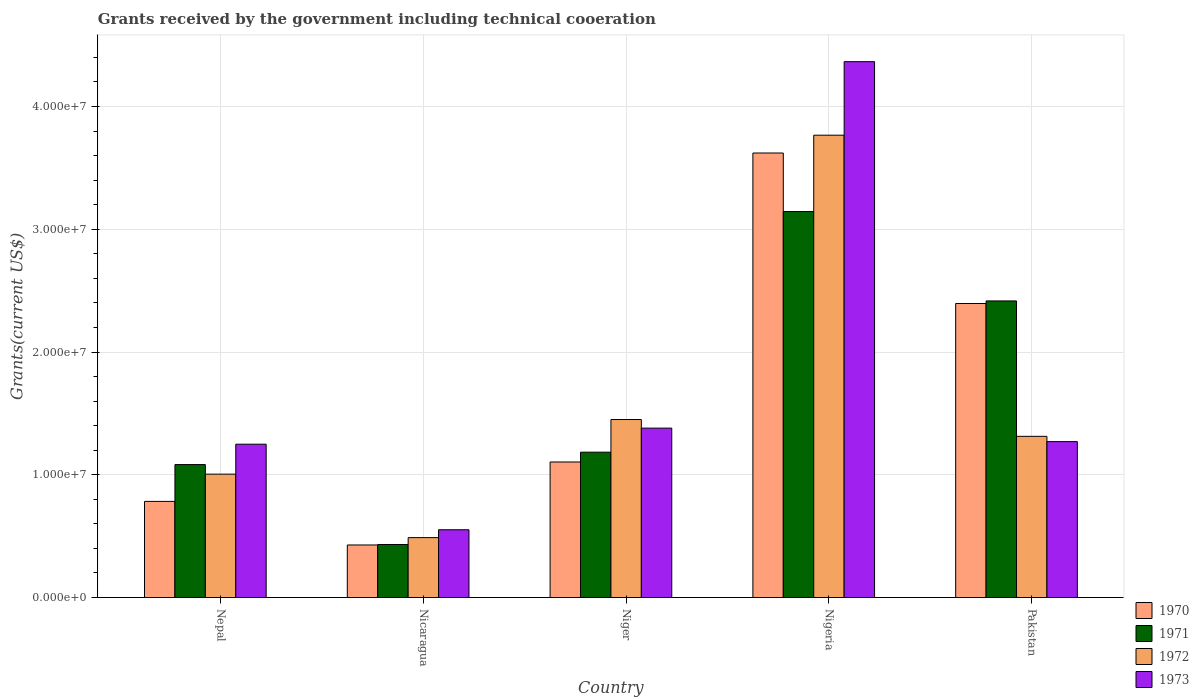Are the number of bars on each tick of the X-axis equal?
Offer a very short reply. Yes. How many bars are there on the 2nd tick from the right?
Provide a short and direct response. 4. What is the label of the 3rd group of bars from the left?
Provide a short and direct response. Niger. What is the total grants received by the government in 1970 in Nigeria?
Offer a terse response. 3.62e+07. Across all countries, what is the maximum total grants received by the government in 1973?
Your answer should be compact. 4.36e+07. Across all countries, what is the minimum total grants received by the government in 1972?
Offer a terse response. 4.88e+06. In which country was the total grants received by the government in 1972 maximum?
Your answer should be very brief. Nigeria. In which country was the total grants received by the government in 1972 minimum?
Offer a terse response. Nicaragua. What is the total total grants received by the government in 1970 in the graph?
Your answer should be very brief. 8.33e+07. What is the difference between the total grants received by the government in 1970 in Nepal and that in Niger?
Your response must be concise. -3.21e+06. What is the difference between the total grants received by the government in 1973 in Nicaragua and the total grants received by the government in 1972 in Nigeria?
Offer a very short reply. -3.21e+07. What is the average total grants received by the government in 1972 per country?
Offer a terse response. 1.60e+07. What is the difference between the total grants received by the government of/in 1972 and total grants received by the government of/in 1971 in Niger?
Your answer should be very brief. 2.66e+06. In how many countries, is the total grants received by the government in 1971 greater than 12000000 US$?
Provide a short and direct response. 2. What is the ratio of the total grants received by the government in 1973 in Nepal to that in Nicaragua?
Your response must be concise. 2.26. Is the total grants received by the government in 1971 in Niger less than that in Nigeria?
Give a very brief answer. Yes. Is the difference between the total grants received by the government in 1972 in Nepal and Pakistan greater than the difference between the total grants received by the government in 1971 in Nepal and Pakistan?
Your answer should be compact. Yes. What is the difference between the highest and the second highest total grants received by the government in 1972?
Offer a very short reply. 2.45e+07. What is the difference between the highest and the lowest total grants received by the government in 1972?
Offer a very short reply. 3.28e+07. Is the sum of the total grants received by the government in 1970 in Niger and Nigeria greater than the maximum total grants received by the government in 1971 across all countries?
Your answer should be very brief. Yes. Is it the case that in every country, the sum of the total grants received by the government in 1973 and total grants received by the government in 1972 is greater than the total grants received by the government in 1971?
Provide a succinct answer. Yes. Are all the bars in the graph horizontal?
Provide a short and direct response. No. How many countries are there in the graph?
Ensure brevity in your answer.  5. How are the legend labels stacked?
Provide a succinct answer. Vertical. What is the title of the graph?
Your response must be concise. Grants received by the government including technical cooeration. Does "1996" appear as one of the legend labels in the graph?
Your answer should be very brief. No. What is the label or title of the X-axis?
Offer a terse response. Country. What is the label or title of the Y-axis?
Provide a short and direct response. Grants(current US$). What is the Grants(current US$) of 1970 in Nepal?
Give a very brief answer. 7.83e+06. What is the Grants(current US$) in 1971 in Nepal?
Your response must be concise. 1.08e+07. What is the Grants(current US$) of 1972 in Nepal?
Provide a succinct answer. 1.00e+07. What is the Grants(current US$) of 1973 in Nepal?
Offer a terse response. 1.25e+07. What is the Grants(current US$) of 1970 in Nicaragua?
Offer a terse response. 4.28e+06. What is the Grants(current US$) in 1971 in Nicaragua?
Your response must be concise. 4.32e+06. What is the Grants(current US$) in 1972 in Nicaragua?
Offer a terse response. 4.88e+06. What is the Grants(current US$) of 1973 in Nicaragua?
Make the answer very short. 5.52e+06. What is the Grants(current US$) in 1970 in Niger?
Provide a short and direct response. 1.10e+07. What is the Grants(current US$) of 1971 in Niger?
Make the answer very short. 1.18e+07. What is the Grants(current US$) of 1972 in Niger?
Make the answer very short. 1.45e+07. What is the Grants(current US$) of 1973 in Niger?
Offer a terse response. 1.38e+07. What is the Grants(current US$) of 1970 in Nigeria?
Your answer should be compact. 3.62e+07. What is the Grants(current US$) in 1971 in Nigeria?
Give a very brief answer. 3.14e+07. What is the Grants(current US$) in 1972 in Nigeria?
Give a very brief answer. 3.77e+07. What is the Grants(current US$) in 1973 in Nigeria?
Offer a terse response. 4.36e+07. What is the Grants(current US$) in 1970 in Pakistan?
Offer a terse response. 2.40e+07. What is the Grants(current US$) of 1971 in Pakistan?
Offer a terse response. 2.42e+07. What is the Grants(current US$) of 1972 in Pakistan?
Ensure brevity in your answer.  1.31e+07. What is the Grants(current US$) of 1973 in Pakistan?
Make the answer very short. 1.27e+07. Across all countries, what is the maximum Grants(current US$) in 1970?
Give a very brief answer. 3.62e+07. Across all countries, what is the maximum Grants(current US$) of 1971?
Give a very brief answer. 3.14e+07. Across all countries, what is the maximum Grants(current US$) of 1972?
Offer a very short reply. 3.77e+07. Across all countries, what is the maximum Grants(current US$) in 1973?
Offer a terse response. 4.36e+07. Across all countries, what is the minimum Grants(current US$) in 1970?
Ensure brevity in your answer.  4.28e+06. Across all countries, what is the minimum Grants(current US$) of 1971?
Ensure brevity in your answer.  4.32e+06. Across all countries, what is the minimum Grants(current US$) in 1972?
Your response must be concise. 4.88e+06. Across all countries, what is the minimum Grants(current US$) of 1973?
Offer a very short reply. 5.52e+06. What is the total Grants(current US$) of 1970 in the graph?
Your answer should be compact. 8.33e+07. What is the total Grants(current US$) of 1971 in the graph?
Your answer should be very brief. 8.26e+07. What is the total Grants(current US$) in 1972 in the graph?
Offer a very short reply. 8.02e+07. What is the total Grants(current US$) in 1973 in the graph?
Keep it short and to the point. 8.82e+07. What is the difference between the Grants(current US$) of 1970 in Nepal and that in Nicaragua?
Keep it short and to the point. 3.55e+06. What is the difference between the Grants(current US$) of 1971 in Nepal and that in Nicaragua?
Make the answer very short. 6.51e+06. What is the difference between the Grants(current US$) in 1972 in Nepal and that in Nicaragua?
Offer a very short reply. 5.17e+06. What is the difference between the Grants(current US$) in 1973 in Nepal and that in Nicaragua?
Offer a terse response. 6.97e+06. What is the difference between the Grants(current US$) of 1970 in Nepal and that in Niger?
Offer a terse response. -3.21e+06. What is the difference between the Grants(current US$) in 1971 in Nepal and that in Niger?
Keep it short and to the point. -1.01e+06. What is the difference between the Grants(current US$) of 1972 in Nepal and that in Niger?
Your response must be concise. -4.45e+06. What is the difference between the Grants(current US$) of 1973 in Nepal and that in Niger?
Keep it short and to the point. -1.31e+06. What is the difference between the Grants(current US$) of 1970 in Nepal and that in Nigeria?
Your response must be concise. -2.84e+07. What is the difference between the Grants(current US$) in 1971 in Nepal and that in Nigeria?
Your response must be concise. -2.06e+07. What is the difference between the Grants(current US$) in 1972 in Nepal and that in Nigeria?
Give a very brief answer. -2.76e+07. What is the difference between the Grants(current US$) of 1973 in Nepal and that in Nigeria?
Offer a terse response. -3.12e+07. What is the difference between the Grants(current US$) of 1970 in Nepal and that in Pakistan?
Provide a short and direct response. -1.61e+07. What is the difference between the Grants(current US$) in 1971 in Nepal and that in Pakistan?
Your answer should be very brief. -1.33e+07. What is the difference between the Grants(current US$) of 1972 in Nepal and that in Pakistan?
Give a very brief answer. -3.08e+06. What is the difference between the Grants(current US$) of 1973 in Nepal and that in Pakistan?
Offer a very short reply. -2.10e+05. What is the difference between the Grants(current US$) of 1970 in Nicaragua and that in Niger?
Offer a terse response. -6.76e+06. What is the difference between the Grants(current US$) of 1971 in Nicaragua and that in Niger?
Offer a terse response. -7.52e+06. What is the difference between the Grants(current US$) in 1972 in Nicaragua and that in Niger?
Provide a short and direct response. -9.62e+06. What is the difference between the Grants(current US$) in 1973 in Nicaragua and that in Niger?
Make the answer very short. -8.28e+06. What is the difference between the Grants(current US$) in 1970 in Nicaragua and that in Nigeria?
Keep it short and to the point. -3.19e+07. What is the difference between the Grants(current US$) in 1971 in Nicaragua and that in Nigeria?
Provide a short and direct response. -2.71e+07. What is the difference between the Grants(current US$) of 1972 in Nicaragua and that in Nigeria?
Your answer should be compact. -3.28e+07. What is the difference between the Grants(current US$) in 1973 in Nicaragua and that in Nigeria?
Your response must be concise. -3.81e+07. What is the difference between the Grants(current US$) of 1970 in Nicaragua and that in Pakistan?
Provide a succinct answer. -1.97e+07. What is the difference between the Grants(current US$) of 1971 in Nicaragua and that in Pakistan?
Offer a terse response. -1.98e+07. What is the difference between the Grants(current US$) of 1972 in Nicaragua and that in Pakistan?
Provide a succinct answer. -8.25e+06. What is the difference between the Grants(current US$) of 1973 in Nicaragua and that in Pakistan?
Your answer should be compact. -7.18e+06. What is the difference between the Grants(current US$) of 1970 in Niger and that in Nigeria?
Give a very brief answer. -2.52e+07. What is the difference between the Grants(current US$) in 1971 in Niger and that in Nigeria?
Make the answer very short. -1.96e+07. What is the difference between the Grants(current US$) of 1972 in Niger and that in Nigeria?
Offer a terse response. -2.32e+07. What is the difference between the Grants(current US$) in 1973 in Niger and that in Nigeria?
Your answer should be very brief. -2.98e+07. What is the difference between the Grants(current US$) in 1970 in Niger and that in Pakistan?
Make the answer very short. -1.29e+07. What is the difference between the Grants(current US$) of 1971 in Niger and that in Pakistan?
Provide a succinct answer. -1.23e+07. What is the difference between the Grants(current US$) of 1972 in Niger and that in Pakistan?
Provide a short and direct response. 1.37e+06. What is the difference between the Grants(current US$) in 1973 in Niger and that in Pakistan?
Keep it short and to the point. 1.10e+06. What is the difference between the Grants(current US$) in 1970 in Nigeria and that in Pakistan?
Your response must be concise. 1.23e+07. What is the difference between the Grants(current US$) in 1971 in Nigeria and that in Pakistan?
Offer a very short reply. 7.28e+06. What is the difference between the Grants(current US$) of 1972 in Nigeria and that in Pakistan?
Your answer should be compact. 2.45e+07. What is the difference between the Grants(current US$) in 1973 in Nigeria and that in Pakistan?
Your answer should be compact. 3.10e+07. What is the difference between the Grants(current US$) in 1970 in Nepal and the Grants(current US$) in 1971 in Nicaragua?
Your response must be concise. 3.51e+06. What is the difference between the Grants(current US$) of 1970 in Nepal and the Grants(current US$) of 1972 in Nicaragua?
Provide a succinct answer. 2.95e+06. What is the difference between the Grants(current US$) in 1970 in Nepal and the Grants(current US$) in 1973 in Nicaragua?
Ensure brevity in your answer.  2.31e+06. What is the difference between the Grants(current US$) in 1971 in Nepal and the Grants(current US$) in 1972 in Nicaragua?
Ensure brevity in your answer.  5.95e+06. What is the difference between the Grants(current US$) of 1971 in Nepal and the Grants(current US$) of 1973 in Nicaragua?
Offer a terse response. 5.31e+06. What is the difference between the Grants(current US$) in 1972 in Nepal and the Grants(current US$) in 1973 in Nicaragua?
Your answer should be very brief. 4.53e+06. What is the difference between the Grants(current US$) of 1970 in Nepal and the Grants(current US$) of 1971 in Niger?
Ensure brevity in your answer.  -4.01e+06. What is the difference between the Grants(current US$) in 1970 in Nepal and the Grants(current US$) in 1972 in Niger?
Your answer should be very brief. -6.67e+06. What is the difference between the Grants(current US$) in 1970 in Nepal and the Grants(current US$) in 1973 in Niger?
Keep it short and to the point. -5.97e+06. What is the difference between the Grants(current US$) of 1971 in Nepal and the Grants(current US$) of 1972 in Niger?
Your answer should be compact. -3.67e+06. What is the difference between the Grants(current US$) in 1971 in Nepal and the Grants(current US$) in 1973 in Niger?
Your answer should be very brief. -2.97e+06. What is the difference between the Grants(current US$) of 1972 in Nepal and the Grants(current US$) of 1973 in Niger?
Keep it short and to the point. -3.75e+06. What is the difference between the Grants(current US$) in 1970 in Nepal and the Grants(current US$) in 1971 in Nigeria?
Your response must be concise. -2.36e+07. What is the difference between the Grants(current US$) of 1970 in Nepal and the Grants(current US$) of 1972 in Nigeria?
Provide a succinct answer. -2.98e+07. What is the difference between the Grants(current US$) in 1970 in Nepal and the Grants(current US$) in 1973 in Nigeria?
Ensure brevity in your answer.  -3.58e+07. What is the difference between the Grants(current US$) of 1971 in Nepal and the Grants(current US$) of 1972 in Nigeria?
Offer a terse response. -2.68e+07. What is the difference between the Grants(current US$) in 1971 in Nepal and the Grants(current US$) in 1973 in Nigeria?
Your answer should be very brief. -3.28e+07. What is the difference between the Grants(current US$) of 1972 in Nepal and the Grants(current US$) of 1973 in Nigeria?
Your answer should be compact. -3.36e+07. What is the difference between the Grants(current US$) of 1970 in Nepal and the Grants(current US$) of 1971 in Pakistan?
Offer a very short reply. -1.63e+07. What is the difference between the Grants(current US$) in 1970 in Nepal and the Grants(current US$) in 1972 in Pakistan?
Your response must be concise. -5.30e+06. What is the difference between the Grants(current US$) of 1970 in Nepal and the Grants(current US$) of 1973 in Pakistan?
Keep it short and to the point. -4.87e+06. What is the difference between the Grants(current US$) in 1971 in Nepal and the Grants(current US$) in 1972 in Pakistan?
Your answer should be very brief. -2.30e+06. What is the difference between the Grants(current US$) in 1971 in Nepal and the Grants(current US$) in 1973 in Pakistan?
Ensure brevity in your answer.  -1.87e+06. What is the difference between the Grants(current US$) of 1972 in Nepal and the Grants(current US$) of 1973 in Pakistan?
Make the answer very short. -2.65e+06. What is the difference between the Grants(current US$) of 1970 in Nicaragua and the Grants(current US$) of 1971 in Niger?
Provide a succinct answer. -7.56e+06. What is the difference between the Grants(current US$) in 1970 in Nicaragua and the Grants(current US$) in 1972 in Niger?
Make the answer very short. -1.02e+07. What is the difference between the Grants(current US$) of 1970 in Nicaragua and the Grants(current US$) of 1973 in Niger?
Offer a terse response. -9.52e+06. What is the difference between the Grants(current US$) of 1971 in Nicaragua and the Grants(current US$) of 1972 in Niger?
Provide a short and direct response. -1.02e+07. What is the difference between the Grants(current US$) in 1971 in Nicaragua and the Grants(current US$) in 1973 in Niger?
Ensure brevity in your answer.  -9.48e+06. What is the difference between the Grants(current US$) of 1972 in Nicaragua and the Grants(current US$) of 1973 in Niger?
Offer a terse response. -8.92e+06. What is the difference between the Grants(current US$) in 1970 in Nicaragua and the Grants(current US$) in 1971 in Nigeria?
Your response must be concise. -2.72e+07. What is the difference between the Grants(current US$) in 1970 in Nicaragua and the Grants(current US$) in 1972 in Nigeria?
Your answer should be compact. -3.34e+07. What is the difference between the Grants(current US$) of 1970 in Nicaragua and the Grants(current US$) of 1973 in Nigeria?
Ensure brevity in your answer.  -3.94e+07. What is the difference between the Grants(current US$) in 1971 in Nicaragua and the Grants(current US$) in 1972 in Nigeria?
Your answer should be very brief. -3.33e+07. What is the difference between the Grants(current US$) in 1971 in Nicaragua and the Grants(current US$) in 1973 in Nigeria?
Ensure brevity in your answer.  -3.93e+07. What is the difference between the Grants(current US$) in 1972 in Nicaragua and the Grants(current US$) in 1973 in Nigeria?
Your answer should be compact. -3.88e+07. What is the difference between the Grants(current US$) of 1970 in Nicaragua and the Grants(current US$) of 1971 in Pakistan?
Offer a terse response. -1.99e+07. What is the difference between the Grants(current US$) in 1970 in Nicaragua and the Grants(current US$) in 1972 in Pakistan?
Make the answer very short. -8.85e+06. What is the difference between the Grants(current US$) of 1970 in Nicaragua and the Grants(current US$) of 1973 in Pakistan?
Keep it short and to the point. -8.42e+06. What is the difference between the Grants(current US$) in 1971 in Nicaragua and the Grants(current US$) in 1972 in Pakistan?
Keep it short and to the point. -8.81e+06. What is the difference between the Grants(current US$) of 1971 in Nicaragua and the Grants(current US$) of 1973 in Pakistan?
Offer a very short reply. -8.38e+06. What is the difference between the Grants(current US$) in 1972 in Nicaragua and the Grants(current US$) in 1973 in Pakistan?
Make the answer very short. -7.82e+06. What is the difference between the Grants(current US$) in 1970 in Niger and the Grants(current US$) in 1971 in Nigeria?
Give a very brief answer. -2.04e+07. What is the difference between the Grants(current US$) of 1970 in Niger and the Grants(current US$) of 1972 in Nigeria?
Ensure brevity in your answer.  -2.66e+07. What is the difference between the Grants(current US$) of 1970 in Niger and the Grants(current US$) of 1973 in Nigeria?
Your answer should be very brief. -3.26e+07. What is the difference between the Grants(current US$) in 1971 in Niger and the Grants(current US$) in 1972 in Nigeria?
Give a very brief answer. -2.58e+07. What is the difference between the Grants(current US$) in 1971 in Niger and the Grants(current US$) in 1973 in Nigeria?
Give a very brief answer. -3.18e+07. What is the difference between the Grants(current US$) in 1972 in Niger and the Grants(current US$) in 1973 in Nigeria?
Provide a succinct answer. -2.92e+07. What is the difference between the Grants(current US$) in 1970 in Niger and the Grants(current US$) in 1971 in Pakistan?
Ensure brevity in your answer.  -1.31e+07. What is the difference between the Grants(current US$) in 1970 in Niger and the Grants(current US$) in 1972 in Pakistan?
Your answer should be compact. -2.09e+06. What is the difference between the Grants(current US$) in 1970 in Niger and the Grants(current US$) in 1973 in Pakistan?
Give a very brief answer. -1.66e+06. What is the difference between the Grants(current US$) of 1971 in Niger and the Grants(current US$) of 1972 in Pakistan?
Keep it short and to the point. -1.29e+06. What is the difference between the Grants(current US$) in 1971 in Niger and the Grants(current US$) in 1973 in Pakistan?
Provide a short and direct response. -8.60e+05. What is the difference between the Grants(current US$) in 1972 in Niger and the Grants(current US$) in 1973 in Pakistan?
Provide a succinct answer. 1.80e+06. What is the difference between the Grants(current US$) in 1970 in Nigeria and the Grants(current US$) in 1971 in Pakistan?
Provide a short and direct response. 1.20e+07. What is the difference between the Grants(current US$) of 1970 in Nigeria and the Grants(current US$) of 1972 in Pakistan?
Offer a very short reply. 2.31e+07. What is the difference between the Grants(current US$) in 1970 in Nigeria and the Grants(current US$) in 1973 in Pakistan?
Keep it short and to the point. 2.35e+07. What is the difference between the Grants(current US$) in 1971 in Nigeria and the Grants(current US$) in 1972 in Pakistan?
Offer a terse response. 1.83e+07. What is the difference between the Grants(current US$) in 1971 in Nigeria and the Grants(current US$) in 1973 in Pakistan?
Provide a short and direct response. 1.87e+07. What is the difference between the Grants(current US$) in 1972 in Nigeria and the Grants(current US$) in 1973 in Pakistan?
Your answer should be compact. 2.50e+07. What is the average Grants(current US$) in 1970 per country?
Ensure brevity in your answer.  1.67e+07. What is the average Grants(current US$) in 1971 per country?
Your answer should be very brief. 1.65e+07. What is the average Grants(current US$) of 1972 per country?
Provide a succinct answer. 1.60e+07. What is the average Grants(current US$) in 1973 per country?
Provide a succinct answer. 1.76e+07. What is the difference between the Grants(current US$) of 1970 and Grants(current US$) of 1971 in Nepal?
Offer a very short reply. -3.00e+06. What is the difference between the Grants(current US$) in 1970 and Grants(current US$) in 1972 in Nepal?
Provide a short and direct response. -2.22e+06. What is the difference between the Grants(current US$) in 1970 and Grants(current US$) in 1973 in Nepal?
Offer a very short reply. -4.66e+06. What is the difference between the Grants(current US$) of 1971 and Grants(current US$) of 1972 in Nepal?
Your response must be concise. 7.80e+05. What is the difference between the Grants(current US$) of 1971 and Grants(current US$) of 1973 in Nepal?
Your answer should be compact. -1.66e+06. What is the difference between the Grants(current US$) of 1972 and Grants(current US$) of 1973 in Nepal?
Offer a very short reply. -2.44e+06. What is the difference between the Grants(current US$) of 1970 and Grants(current US$) of 1972 in Nicaragua?
Offer a terse response. -6.00e+05. What is the difference between the Grants(current US$) of 1970 and Grants(current US$) of 1973 in Nicaragua?
Offer a very short reply. -1.24e+06. What is the difference between the Grants(current US$) in 1971 and Grants(current US$) in 1972 in Nicaragua?
Give a very brief answer. -5.60e+05. What is the difference between the Grants(current US$) of 1971 and Grants(current US$) of 1973 in Nicaragua?
Make the answer very short. -1.20e+06. What is the difference between the Grants(current US$) in 1972 and Grants(current US$) in 1973 in Nicaragua?
Your response must be concise. -6.40e+05. What is the difference between the Grants(current US$) in 1970 and Grants(current US$) in 1971 in Niger?
Give a very brief answer. -8.00e+05. What is the difference between the Grants(current US$) in 1970 and Grants(current US$) in 1972 in Niger?
Offer a very short reply. -3.46e+06. What is the difference between the Grants(current US$) in 1970 and Grants(current US$) in 1973 in Niger?
Offer a very short reply. -2.76e+06. What is the difference between the Grants(current US$) in 1971 and Grants(current US$) in 1972 in Niger?
Keep it short and to the point. -2.66e+06. What is the difference between the Grants(current US$) in 1971 and Grants(current US$) in 1973 in Niger?
Give a very brief answer. -1.96e+06. What is the difference between the Grants(current US$) in 1970 and Grants(current US$) in 1971 in Nigeria?
Your answer should be compact. 4.77e+06. What is the difference between the Grants(current US$) in 1970 and Grants(current US$) in 1972 in Nigeria?
Offer a terse response. -1.45e+06. What is the difference between the Grants(current US$) of 1970 and Grants(current US$) of 1973 in Nigeria?
Your answer should be very brief. -7.44e+06. What is the difference between the Grants(current US$) of 1971 and Grants(current US$) of 1972 in Nigeria?
Keep it short and to the point. -6.22e+06. What is the difference between the Grants(current US$) in 1971 and Grants(current US$) in 1973 in Nigeria?
Make the answer very short. -1.22e+07. What is the difference between the Grants(current US$) in 1972 and Grants(current US$) in 1973 in Nigeria?
Make the answer very short. -5.99e+06. What is the difference between the Grants(current US$) in 1970 and Grants(current US$) in 1971 in Pakistan?
Your answer should be very brief. -2.10e+05. What is the difference between the Grants(current US$) in 1970 and Grants(current US$) in 1972 in Pakistan?
Provide a short and direct response. 1.08e+07. What is the difference between the Grants(current US$) of 1970 and Grants(current US$) of 1973 in Pakistan?
Keep it short and to the point. 1.12e+07. What is the difference between the Grants(current US$) in 1971 and Grants(current US$) in 1972 in Pakistan?
Provide a succinct answer. 1.10e+07. What is the difference between the Grants(current US$) of 1971 and Grants(current US$) of 1973 in Pakistan?
Your answer should be very brief. 1.15e+07. What is the ratio of the Grants(current US$) in 1970 in Nepal to that in Nicaragua?
Ensure brevity in your answer.  1.83. What is the ratio of the Grants(current US$) of 1971 in Nepal to that in Nicaragua?
Your response must be concise. 2.51. What is the ratio of the Grants(current US$) of 1972 in Nepal to that in Nicaragua?
Your answer should be very brief. 2.06. What is the ratio of the Grants(current US$) of 1973 in Nepal to that in Nicaragua?
Make the answer very short. 2.26. What is the ratio of the Grants(current US$) in 1970 in Nepal to that in Niger?
Provide a succinct answer. 0.71. What is the ratio of the Grants(current US$) of 1971 in Nepal to that in Niger?
Keep it short and to the point. 0.91. What is the ratio of the Grants(current US$) in 1972 in Nepal to that in Niger?
Your answer should be compact. 0.69. What is the ratio of the Grants(current US$) in 1973 in Nepal to that in Niger?
Provide a short and direct response. 0.91. What is the ratio of the Grants(current US$) of 1970 in Nepal to that in Nigeria?
Ensure brevity in your answer.  0.22. What is the ratio of the Grants(current US$) of 1971 in Nepal to that in Nigeria?
Offer a terse response. 0.34. What is the ratio of the Grants(current US$) of 1972 in Nepal to that in Nigeria?
Make the answer very short. 0.27. What is the ratio of the Grants(current US$) in 1973 in Nepal to that in Nigeria?
Make the answer very short. 0.29. What is the ratio of the Grants(current US$) in 1970 in Nepal to that in Pakistan?
Provide a succinct answer. 0.33. What is the ratio of the Grants(current US$) in 1971 in Nepal to that in Pakistan?
Give a very brief answer. 0.45. What is the ratio of the Grants(current US$) in 1972 in Nepal to that in Pakistan?
Give a very brief answer. 0.77. What is the ratio of the Grants(current US$) in 1973 in Nepal to that in Pakistan?
Keep it short and to the point. 0.98. What is the ratio of the Grants(current US$) in 1970 in Nicaragua to that in Niger?
Your answer should be compact. 0.39. What is the ratio of the Grants(current US$) of 1971 in Nicaragua to that in Niger?
Ensure brevity in your answer.  0.36. What is the ratio of the Grants(current US$) in 1972 in Nicaragua to that in Niger?
Your response must be concise. 0.34. What is the ratio of the Grants(current US$) of 1970 in Nicaragua to that in Nigeria?
Give a very brief answer. 0.12. What is the ratio of the Grants(current US$) of 1971 in Nicaragua to that in Nigeria?
Give a very brief answer. 0.14. What is the ratio of the Grants(current US$) in 1972 in Nicaragua to that in Nigeria?
Provide a short and direct response. 0.13. What is the ratio of the Grants(current US$) in 1973 in Nicaragua to that in Nigeria?
Keep it short and to the point. 0.13. What is the ratio of the Grants(current US$) in 1970 in Nicaragua to that in Pakistan?
Your answer should be very brief. 0.18. What is the ratio of the Grants(current US$) in 1971 in Nicaragua to that in Pakistan?
Provide a succinct answer. 0.18. What is the ratio of the Grants(current US$) of 1972 in Nicaragua to that in Pakistan?
Provide a short and direct response. 0.37. What is the ratio of the Grants(current US$) in 1973 in Nicaragua to that in Pakistan?
Offer a very short reply. 0.43. What is the ratio of the Grants(current US$) in 1970 in Niger to that in Nigeria?
Offer a terse response. 0.3. What is the ratio of the Grants(current US$) in 1971 in Niger to that in Nigeria?
Ensure brevity in your answer.  0.38. What is the ratio of the Grants(current US$) in 1972 in Niger to that in Nigeria?
Keep it short and to the point. 0.39. What is the ratio of the Grants(current US$) of 1973 in Niger to that in Nigeria?
Provide a succinct answer. 0.32. What is the ratio of the Grants(current US$) of 1970 in Niger to that in Pakistan?
Your response must be concise. 0.46. What is the ratio of the Grants(current US$) in 1971 in Niger to that in Pakistan?
Provide a succinct answer. 0.49. What is the ratio of the Grants(current US$) in 1972 in Niger to that in Pakistan?
Your answer should be very brief. 1.1. What is the ratio of the Grants(current US$) in 1973 in Niger to that in Pakistan?
Offer a very short reply. 1.09. What is the ratio of the Grants(current US$) of 1970 in Nigeria to that in Pakistan?
Provide a short and direct response. 1.51. What is the ratio of the Grants(current US$) in 1971 in Nigeria to that in Pakistan?
Your answer should be very brief. 1.3. What is the ratio of the Grants(current US$) in 1972 in Nigeria to that in Pakistan?
Offer a very short reply. 2.87. What is the ratio of the Grants(current US$) in 1973 in Nigeria to that in Pakistan?
Keep it short and to the point. 3.44. What is the difference between the highest and the second highest Grants(current US$) in 1970?
Provide a succinct answer. 1.23e+07. What is the difference between the highest and the second highest Grants(current US$) in 1971?
Give a very brief answer. 7.28e+06. What is the difference between the highest and the second highest Grants(current US$) in 1972?
Offer a very short reply. 2.32e+07. What is the difference between the highest and the second highest Grants(current US$) of 1973?
Ensure brevity in your answer.  2.98e+07. What is the difference between the highest and the lowest Grants(current US$) of 1970?
Make the answer very short. 3.19e+07. What is the difference between the highest and the lowest Grants(current US$) of 1971?
Provide a succinct answer. 2.71e+07. What is the difference between the highest and the lowest Grants(current US$) in 1972?
Make the answer very short. 3.28e+07. What is the difference between the highest and the lowest Grants(current US$) of 1973?
Offer a very short reply. 3.81e+07. 